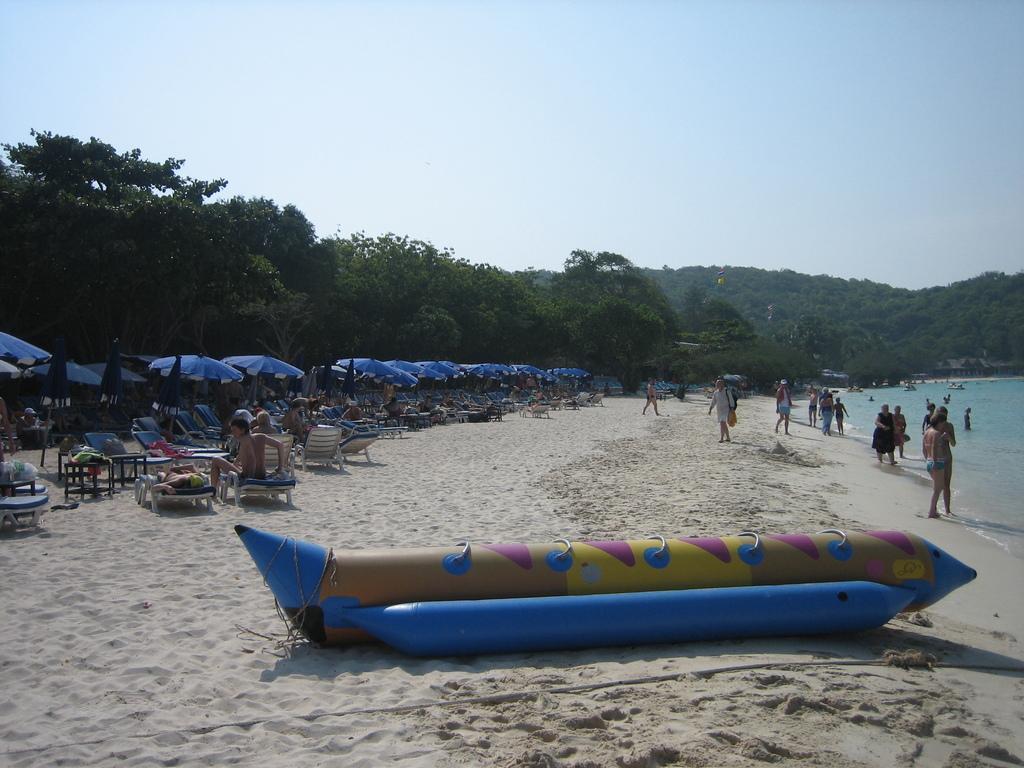Could you give a brief overview of what you see in this image? In this image, we can see some umbrellas and some rest chairs, there are some people standing on the sand, we can see water, there are some green trees, at the top we can see the sky. 